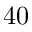Convert formula to latex. <formula><loc_0><loc_0><loc_500><loc_500>4 0</formula> 